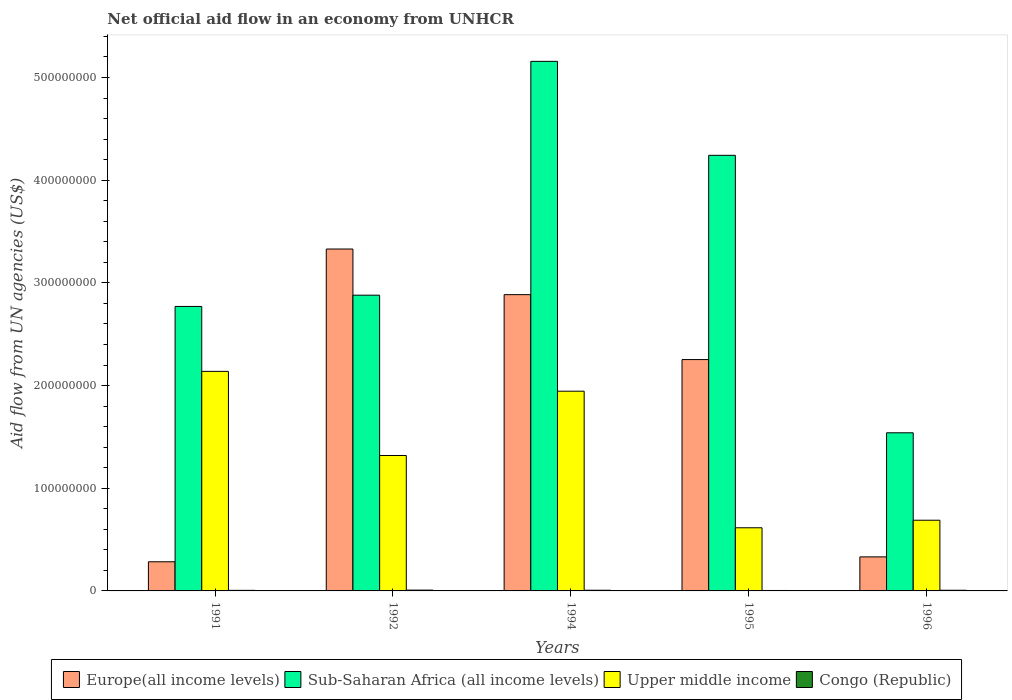Are the number of bars per tick equal to the number of legend labels?
Give a very brief answer. Yes. How many bars are there on the 3rd tick from the right?
Ensure brevity in your answer.  4. In how many cases, is the number of bars for a given year not equal to the number of legend labels?
Make the answer very short. 0. What is the net official aid flow in Upper middle income in 1994?
Provide a succinct answer. 1.94e+08. Across all years, what is the maximum net official aid flow in Europe(all income levels)?
Your response must be concise. 3.33e+08. What is the total net official aid flow in Europe(all income levels) in the graph?
Your response must be concise. 9.08e+08. What is the difference between the net official aid flow in Europe(all income levels) in 1991 and that in 1996?
Your answer should be compact. -4.75e+06. What is the difference between the net official aid flow in Congo (Republic) in 1992 and the net official aid flow in Europe(all income levels) in 1991?
Your answer should be compact. -2.76e+07. What is the average net official aid flow in Upper middle income per year?
Offer a terse response. 1.34e+08. In the year 1991, what is the difference between the net official aid flow in Congo (Republic) and net official aid flow in Upper middle income?
Provide a succinct answer. -2.13e+08. In how many years, is the net official aid flow in Upper middle income greater than 420000000 US$?
Make the answer very short. 0. What is the ratio of the net official aid flow in Upper middle income in 1994 to that in 1996?
Your answer should be compact. 2.83. What is the difference between the highest and the second highest net official aid flow in Sub-Saharan Africa (all income levels)?
Offer a very short reply. 9.15e+07. Is it the case that in every year, the sum of the net official aid flow in Upper middle income and net official aid flow in Sub-Saharan Africa (all income levels) is greater than the sum of net official aid flow in Europe(all income levels) and net official aid flow in Congo (Republic)?
Provide a succinct answer. No. What does the 2nd bar from the left in 1994 represents?
Offer a terse response. Sub-Saharan Africa (all income levels). What does the 4th bar from the right in 1992 represents?
Offer a very short reply. Europe(all income levels). Is it the case that in every year, the sum of the net official aid flow in Europe(all income levels) and net official aid flow in Sub-Saharan Africa (all income levels) is greater than the net official aid flow in Congo (Republic)?
Offer a terse response. Yes. How many years are there in the graph?
Your response must be concise. 5. What is the difference between two consecutive major ticks on the Y-axis?
Your answer should be very brief. 1.00e+08. Are the values on the major ticks of Y-axis written in scientific E-notation?
Ensure brevity in your answer.  No. Does the graph contain grids?
Your answer should be compact. No. Where does the legend appear in the graph?
Make the answer very short. Bottom center. How many legend labels are there?
Provide a short and direct response. 4. What is the title of the graph?
Provide a succinct answer. Net official aid flow in an economy from UNHCR. Does "Papua New Guinea" appear as one of the legend labels in the graph?
Provide a short and direct response. No. What is the label or title of the X-axis?
Give a very brief answer. Years. What is the label or title of the Y-axis?
Your answer should be very brief. Aid flow from UN agencies (US$). What is the Aid flow from UN agencies (US$) of Europe(all income levels) in 1991?
Keep it short and to the point. 2.84e+07. What is the Aid flow from UN agencies (US$) in Sub-Saharan Africa (all income levels) in 1991?
Keep it short and to the point. 2.77e+08. What is the Aid flow from UN agencies (US$) of Upper middle income in 1991?
Offer a very short reply. 2.14e+08. What is the Aid flow from UN agencies (US$) in Congo (Republic) in 1991?
Offer a terse response. 5.50e+05. What is the Aid flow from UN agencies (US$) of Europe(all income levels) in 1992?
Your answer should be compact. 3.33e+08. What is the Aid flow from UN agencies (US$) of Sub-Saharan Africa (all income levels) in 1992?
Ensure brevity in your answer.  2.88e+08. What is the Aid flow from UN agencies (US$) in Upper middle income in 1992?
Keep it short and to the point. 1.32e+08. What is the Aid flow from UN agencies (US$) in Congo (Republic) in 1992?
Your response must be concise. 7.80e+05. What is the Aid flow from UN agencies (US$) in Europe(all income levels) in 1994?
Offer a very short reply. 2.89e+08. What is the Aid flow from UN agencies (US$) of Sub-Saharan Africa (all income levels) in 1994?
Keep it short and to the point. 5.16e+08. What is the Aid flow from UN agencies (US$) of Upper middle income in 1994?
Provide a short and direct response. 1.94e+08. What is the Aid flow from UN agencies (US$) of Congo (Republic) in 1994?
Provide a short and direct response. 6.60e+05. What is the Aid flow from UN agencies (US$) in Europe(all income levels) in 1995?
Make the answer very short. 2.25e+08. What is the Aid flow from UN agencies (US$) in Sub-Saharan Africa (all income levels) in 1995?
Provide a succinct answer. 4.24e+08. What is the Aid flow from UN agencies (US$) in Upper middle income in 1995?
Offer a very short reply. 6.15e+07. What is the Aid flow from UN agencies (US$) of Congo (Republic) in 1995?
Ensure brevity in your answer.  4.30e+05. What is the Aid flow from UN agencies (US$) of Europe(all income levels) in 1996?
Your answer should be very brief. 3.31e+07. What is the Aid flow from UN agencies (US$) of Sub-Saharan Africa (all income levels) in 1996?
Make the answer very short. 1.54e+08. What is the Aid flow from UN agencies (US$) of Upper middle income in 1996?
Your answer should be very brief. 6.88e+07. What is the Aid flow from UN agencies (US$) in Congo (Republic) in 1996?
Provide a short and direct response. 6.50e+05. Across all years, what is the maximum Aid flow from UN agencies (US$) in Europe(all income levels)?
Your answer should be very brief. 3.33e+08. Across all years, what is the maximum Aid flow from UN agencies (US$) of Sub-Saharan Africa (all income levels)?
Offer a very short reply. 5.16e+08. Across all years, what is the maximum Aid flow from UN agencies (US$) of Upper middle income?
Your response must be concise. 2.14e+08. Across all years, what is the maximum Aid flow from UN agencies (US$) of Congo (Republic)?
Your response must be concise. 7.80e+05. Across all years, what is the minimum Aid flow from UN agencies (US$) of Europe(all income levels)?
Your answer should be compact. 2.84e+07. Across all years, what is the minimum Aid flow from UN agencies (US$) in Sub-Saharan Africa (all income levels)?
Provide a short and direct response. 1.54e+08. Across all years, what is the minimum Aid flow from UN agencies (US$) in Upper middle income?
Offer a terse response. 6.15e+07. What is the total Aid flow from UN agencies (US$) of Europe(all income levels) in the graph?
Your answer should be compact. 9.08e+08. What is the total Aid flow from UN agencies (US$) of Sub-Saharan Africa (all income levels) in the graph?
Make the answer very short. 1.66e+09. What is the total Aid flow from UN agencies (US$) of Upper middle income in the graph?
Your response must be concise. 6.71e+08. What is the total Aid flow from UN agencies (US$) of Congo (Republic) in the graph?
Offer a terse response. 3.07e+06. What is the difference between the Aid flow from UN agencies (US$) in Europe(all income levels) in 1991 and that in 1992?
Offer a terse response. -3.05e+08. What is the difference between the Aid flow from UN agencies (US$) of Sub-Saharan Africa (all income levels) in 1991 and that in 1992?
Offer a very short reply. -1.10e+07. What is the difference between the Aid flow from UN agencies (US$) of Upper middle income in 1991 and that in 1992?
Provide a succinct answer. 8.19e+07. What is the difference between the Aid flow from UN agencies (US$) in Europe(all income levels) in 1991 and that in 1994?
Offer a terse response. -2.60e+08. What is the difference between the Aid flow from UN agencies (US$) in Sub-Saharan Africa (all income levels) in 1991 and that in 1994?
Offer a terse response. -2.39e+08. What is the difference between the Aid flow from UN agencies (US$) in Upper middle income in 1991 and that in 1994?
Offer a very short reply. 1.93e+07. What is the difference between the Aid flow from UN agencies (US$) in Europe(all income levels) in 1991 and that in 1995?
Offer a very short reply. -1.97e+08. What is the difference between the Aid flow from UN agencies (US$) in Sub-Saharan Africa (all income levels) in 1991 and that in 1995?
Your response must be concise. -1.47e+08. What is the difference between the Aid flow from UN agencies (US$) of Upper middle income in 1991 and that in 1995?
Keep it short and to the point. 1.52e+08. What is the difference between the Aid flow from UN agencies (US$) in Congo (Republic) in 1991 and that in 1995?
Give a very brief answer. 1.20e+05. What is the difference between the Aid flow from UN agencies (US$) in Europe(all income levels) in 1991 and that in 1996?
Your answer should be compact. -4.75e+06. What is the difference between the Aid flow from UN agencies (US$) in Sub-Saharan Africa (all income levels) in 1991 and that in 1996?
Ensure brevity in your answer.  1.23e+08. What is the difference between the Aid flow from UN agencies (US$) of Upper middle income in 1991 and that in 1996?
Offer a terse response. 1.45e+08. What is the difference between the Aid flow from UN agencies (US$) of Congo (Republic) in 1991 and that in 1996?
Make the answer very short. -1.00e+05. What is the difference between the Aid flow from UN agencies (US$) of Europe(all income levels) in 1992 and that in 1994?
Keep it short and to the point. 4.44e+07. What is the difference between the Aid flow from UN agencies (US$) of Sub-Saharan Africa (all income levels) in 1992 and that in 1994?
Keep it short and to the point. -2.28e+08. What is the difference between the Aid flow from UN agencies (US$) of Upper middle income in 1992 and that in 1994?
Keep it short and to the point. -6.26e+07. What is the difference between the Aid flow from UN agencies (US$) in Europe(all income levels) in 1992 and that in 1995?
Offer a very short reply. 1.08e+08. What is the difference between the Aid flow from UN agencies (US$) of Sub-Saharan Africa (all income levels) in 1992 and that in 1995?
Keep it short and to the point. -1.36e+08. What is the difference between the Aid flow from UN agencies (US$) in Upper middle income in 1992 and that in 1995?
Keep it short and to the point. 7.04e+07. What is the difference between the Aid flow from UN agencies (US$) of Europe(all income levels) in 1992 and that in 1996?
Your response must be concise. 3.00e+08. What is the difference between the Aid flow from UN agencies (US$) of Sub-Saharan Africa (all income levels) in 1992 and that in 1996?
Your answer should be very brief. 1.34e+08. What is the difference between the Aid flow from UN agencies (US$) of Upper middle income in 1992 and that in 1996?
Your answer should be compact. 6.30e+07. What is the difference between the Aid flow from UN agencies (US$) of Congo (Republic) in 1992 and that in 1996?
Your response must be concise. 1.30e+05. What is the difference between the Aid flow from UN agencies (US$) of Europe(all income levels) in 1994 and that in 1995?
Offer a very short reply. 6.32e+07. What is the difference between the Aid flow from UN agencies (US$) in Sub-Saharan Africa (all income levels) in 1994 and that in 1995?
Keep it short and to the point. 9.15e+07. What is the difference between the Aid flow from UN agencies (US$) in Upper middle income in 1994 and that in 1995?
Your response must be concise. 1.33e+08. What is the difference between the Aid flow from UN agencies (US$) in Europe(all income levels) in 1994 and that in 1996?
Offer a terse response. 2.55e+08. What is the difference between the Aid flow from UN agencies (US$) in Sub-Saharan Africa (all income levels) in 1994 and that in 1996?
Provide a succinct answer. 3.62e+08. What is the difference between the Aid flow from UN agencies (US$) in Upper middle income in 1994 and that in 1996?
Give a very brief answer. 1.26e+08. What is the difference between the Aid flow from UN agencies (US$) in Europe(all income levels) in 1995 and that in 1996?
Your response must be concise. 1.92e+08. What is the difference between the Aid flow from UN agencies (US$) of Sub-Saharan Africa (all income levels) in 1995 and that in 1996?
Offer a terse response. 2.70e+08. What is the difference between the Aid flow from UN agencies (US$) in Upper middle income in 1995 and that in 1996?
Your answer should be compact. -7.34e+06. What is the difference between the Aid flow from UN agencies (US$) in Europe(all income levels) in 1991 and the Aid flow from UN agencies (US$) in Sub-Saharan Africa (all income levels) in 1992?
Keep it short and to the point. -2.60e+08. What is the difference between the Aid flow from UN agencies (US$) of Europe(all income levels) in 1991 and the Aid flow from UN agencies (US$) of Upper middle income in 1992?
Your response must be concise. -1.03e+08. What is the difference between the Aid flow from UN agencies (US$) in Europe(all income levels) in 1991 and the Aid flow from UN agencies (US$) in Congo (Republic) in 1992?
Keep it short and to the point. 2.76e+07. What is the difference between the Aid flow from UN agencies (US$) in Sub-Saharan Africa (all income levels) in 1991 and the Aid flow from UN agencies (US$) in Upper middle income in 1992?
Your answer should be compact. 1.45e+08. What is the difference between the Aid flow from UN agencies (US$) in Sub-Saharan Africa (all income levels) in 1991 and the Aid flow from UN agencies (US$) in Congo (Republic) in 1992?
Keep it short and to the point. 2.76e+08. What is the difference between the Aid flow from UN agencies (US$) in Upper middle income in 1991 and the Aid flow from UN agencies (US$) in Congo (Republic) in 1992?
Your answer should be very brief. 2.13e+08. What is the difference between the Aid flow from UN agencies (US$) in Europe(all income levels) in 1991 and the Aid flow from UN agencies (US$) in Sub-Saharan Africa (all income levels) in 1994?
Offer a very short reply. -4.87e+08. What is the difference between the Aid flow from UN agencies (US$) in Europe(all income levels) in 1991 and the Aid flow from UN agencies (US$) in Upper middle income in 1994?
Your answer should be very brief. -1.66e+08. What is the difference between the Aid flow from UN agencies (US$) of Europe(all income levels) in 1991 and the Aid flow from UN agencies (US$) of Congo (Republic) in 1994?
Offer a terse response. 2.77e+07. What is the difference between the Aid flow from UN agencies (US$) of Sub-Saharan Africa (all income levels) in 1991 and the Aid flow from UN agencies (US$) of Upper middle income in 1994?
Give a very brief answer. 8.25e+07. What is the difference between the Aid flow from UN agencies (US$) in Sub-Saharan Africa (all income levels) in 1991 and the Aid flow from UN agencies (US$) in Congo (Republic) in 1994?
Provide a short and direct response. 2.76e+08. What is the difference between the Aid flow from UN agencies (US$) of Upper middle income in 1991 and the Aid flow from UN agencies (US$) of Congo (Republic) in 1994?
Ensure brevity in your answer.  2.13e+08. What is the difference between the Aid flow from UN agencies (US$) of Europe(all income levels) in 1991 and the Aid flow from UN agencies (US$) of Sub-Saharan Africa (all income levels) in 1995?
Your answer should be compact. -3.96e+08. What is the difference between the Aid flow from UN agencies (US$) in Europe(all income levels) in 1991 and the Aid flow from UN agencies (US$) in Upper middle income in 1995?
Keep it short and to the point. -3.31e+07. What is the difference between the Aid flow from UN agencies (US$) in Europe(all income levels) in 1991 and the Aid flow from UN agencies (US$) in Congo (Republic) in 1995?
Your answer should be very brief. 2.80e+07. What is the difference between the Aid flow from UN agencies (US$) of Sub-Saharan Africa (all income levels) in 1991 and the Aid flow from UN agencies (US$) of Upper middle income in 1995?
Your answer should be very brief. 2.16e+08. What is the difference between the Aid flow from UN agencies (US$) in Sub-Saharan Africa (all income levels) in 1991 and the Aid flow from UN agencies (US$) in Congo (Republic) in 1995?
Your response must be concise. 2.77e+08. What is the difference between the Aid flow from UN agencies (US$) in Upper middle income in 1991 and the Aid flow from UN agencies (US$) in Congo (Republic) in 1995?
Keep it short and to the point. 2.13e+08. What is the difference between the Aid flow from UN agencies (US$) in Europe(all income levels) in 1991 and the Aid flow from UN agencies (US$) in Sub-Saharan Africa (all income levels) in 1996?
Offer a very short reply. -1.26e+08. What is the difference between the Aid flow from UN agencies (US$) in Europe(all income levels) in 1991 and the Aid flow from UN agencies (US$) in Upper middle income in 1996?
Your answer should be very brief. -4.04e+07. What is the difference between the Aid flow from UN agencies (US$) in Europe(all income levels) in 1991 and the Aid flow from UN agencies (US$) in Congo (Republic) in 1996?
Your answer should be very brief. 2.77e+07. What is the difference between the Aid flow from UN agencies (US$) in Sub-Saharan Africa (all income levels) in 1991 and the Aid flow from UN agencies (US$) in Upper middle income in 1996?
Provide a succinct answer. 2.08e+08. What is the difference between the Aid flow from UN agencies (US$) in Sub-Saharan Africa (all income levels) in 1991 and the Aid flow from UN agencies (US$) in Congo (Republic) in 1996?
Your answer should be compact. 2.76e+08. What is the difference between the Aid flow from UN agencies (US$) of Upper middle income in 1991 and the Aid flow from UN agencies (US$) of Congo (Republic) in 1996?
Ensure brevity in your answer.  2.13e+08. What is the difference between the Aid flow from UN agencies (US$) in Europe(all income levels) in 1992 and the Aid flow from UN agencies (US$) in Sub-Saharan Africa (all income levels) in 1994?
Make the answer very short. -1.83e+08. What is the difference between the Aid flow from UN agencies (US$) of Europe(all income levels) in 1992 and the Aid flow from UN agencies (US$) of Upper middle income in 1994?
Offer a terse response. 1.38e+08. What is the difference between the Aid flow from UN agencies (US$) in Europe(all income levels) in 1992 and the Aid flow from UN agencies (US$) in Congo (Republic) in 1994?
Make the answer very short. 3.32e+08. What is the difference between the Aid flow from UN agencies (US$) in Sub-Saharan Africa (all income levels) in 1992 and the Aid flow from UN agencies (US$) in Upper middle income in 1994?
Provide a short and direct response. 9.35e+07. What is the difference between the Aid flow from UN agencies (US$) in Sub-Saharan Africa (all income levels) in 1992 and the Aid flow from UN agencies (US$) in Congo (Republic) in 1994?
Your answer should be compact. 2.87e+08. What is the difference between the Aid flow from UN agencies (US$) in Upper middle income in 1992 and the Aid flow from UN agencies (US$) in Congo (Republic) in 1994?
Make the answer very short. 1.31e+08. What is the difference between the Aid flow from UN agencies (US$) in Europe(all income levels) in 1992 and the Aid flow from UN agencies (US$) in Sub-Saharan Africa (all income levels) in 1995?
Offer a very short reply. -9.12e+07. What is the difference between the Aid flow from UN agencies (US$) in Europe(all income levels) in 1992 and the Aid flow from UN agencies (US$) in Upper middle income in 1995?
Give a very brief answer. 2.71e+08. What is the difference between the Aid flow from UN agencies (US$) in Europe(all income levels) in 1992 and the Aid flow from UN agencies (US$) in Congo (Republic) in 1995?
Ensure brevity in your answer.  3.33e+08. What is the difference between the Aid flow from UN agencies (US$) in Sub-Saharan Africa (all income levels) in 1992 and the Aid flow from UN agencies (US$) in Upper middle income in 1995?
Keep it short and to the point. 2.26e+08. What is the difference between the Aid flow from UN agencies (US$) in Sub-Saharan Africa (all income levels) in 1992 and the Aid flow from UN agencies (US$) in Congo (Republic) in 1995?
Offer a very short reply. 2.88e+08. What is the difference between the Aid flow from UN agencies (US$) of Upper middle income in 1992 and the Aid flow from UN agencies (US$) of Congo (Republic) in 1995?
Ensure brevity in your answer.  1.31e+08. What is the difference between the Aid flow from UN agencies (US$) of Europe(all income levels) in 1992 and the Aid flow from UN agencies (US$) of Sub-Saharan Africa (all income levels) in 1996?
Provide a short and direct response. 1.79e+08. What is the difference between the Aid flow from UN agencies (US$) in Europe(all income levels) in 1992 and the Aid flow from UN agencies (US$) in Upper middle income in 1996?
Provide a succinct answer. 2.64e+08. What is the difference between the Aid flow from UN agencies (US$) of Europe(all income levels) in 1992 and the Aid flow from UN agencies (US$) of Congo (Republic) in 1996?
Ensure brevity in your answer.  3.32e+08. What is the difference between the Aid flow from UN agencies (US$) in Sub-Saharan Africa (all income levels) in 1992 and the Aid flow from UN agencies (US$) in Upper middle income in 1996?
Ensure brevity in your answer.  2.19e+08. What is the difference between the Aid flow from UN agencies (US$) in Sub-Saharan Africa (all income levels) in 1992 and the Aid flow from UN agencies (US$) in Congo (Republic) in 1996?
Your answer should be compact. 2.87e+08. What is the difference between the Aid flow from UN agencies (US$) of Upper middle income in 1992 and the Aid flow from UN agencies (US$) of Congo (Republic) in 1996?
Give a very brief answer. 1.31e+08. What is the difference between the Aid flow from UN agencies (US$) of Europe(all income levels) in 1994 and the Aid flow from UN agencies (US$) of Sub-Saharan Africa (all income levels) in 1995?
Make the answer very short. -1.36e+08. What is the difference between the Aid flow from UN agencies (US$) in Europe(all income levels) in 1994 and the Aid flow from UN agencies (US$) in Upper middle income in 1995?
Make the answer very short. 2.27e+08. What is the difference between the Aid flow from UN agencies (US$) of Europe(all income levels) in 1994 and the Aid flow from UN agencies (US$) of Congo (Republic) in 1995?
Keep it short and to the point. 2.88e+08. What is the difference between the Aid flow from UN agencies (US$) in Sub-Saharan Africa (all income levels) in 1994 and the Aid flow from UN agencies (US$) in Upper middle income in 1995?
Give a very brief answer. 4.54e+08. What is the difference between the Aid flow from UN agencies (US$) of Sub-Saharan Africa (all income levels) in 1994 and the Aid flow from UN agencies (US$) of Congo (Republic) in 1995?
Your answer should be compact. 5.15e+08. What is the difference between the Aid flow from UN agencies (US$) in Upper middle income in 1994 and the Aid flow from UN agencies (US$) in Congo (Republic) in 1995?
Your answer should be compact. 1.94e+08. What is the difference between the Aid flow from UN agencies (US$) in Europe(all income levels) in 1994 and the Aid flow from UN agencies (US$) in Sub-Saharan Africa (all income levels) in 1996?
Make the answer very short. 1.35e+08. What is the difference between the Aid flow from UN agencies (US$) in Europe(all income levels) in 1994 and the Aid flow from UN agencies (US$) in Upper middle income in 1996?
Offer a very short reply. 2.20e+08. What is the difference between the Aid flow from UN agencies (US$) in Europe(all income levels) in 1994 and the Aid flow from UN agencies (US$) in Congo (Republic) in 1996?
Offer a terse response. 2.88e+08. What is the difference between the Aid flow from UN agencies (US$) in Sub-Saharan Africa (all income levels) in 1994 and the Aid flow from UN agencies (US$) in Upper middle income in 1996?
Give a very brief answer. 4.47e+08. What is the difference between the Aid flow from UN agencies (US$) in Sub-Saharan Africa (all income levels) in 1994 and the Aid flow from UN agencies (US$) in Congo (Republic) in 1996?
Make the answer very short. 5.15e+08. What is the difference between the Aid flow from UN agencies (US$) in Upper middle income in 1994 and the Aid flow from UN agencies (US$) in Congo (Republic) in 1996?
Your answer should be very brief. 1.94e+08. What is the difference between the Aid flow from UN agencies (US$) in Europe(all income levels) in 1995 and the Aid flow from UN agencies (US$) in Sub-Saharan Africa (all income levels) in 1996?
Offer a terse response. 7.13e+07. What is the difference between the Aid flow from UN agencies (US$) of Europe(all income levels) in 1995 and the Aid flow from UN agencies (US$) of Upper middle income in 1996?
Ensure brevity in your answer.  1.56e+08. What is the difference between the Aid flow from UN agencies (US$) in Europe(all income levels) in 1995 and the Aid flow from UN agencies (US$) in Congo (Republic) in 1996?
Ensure brevity in your answer.  2.25e+08. What is the difference between the Aid flow from UN agencies (US$) in Sub-Saharan Africa (all income levels) in 1995 and the Aid flow from UN agencies (US$) in Upper middle income in 1996?
Offer a terse response. 3.55e+08. What is the difference between the Aid flow from UN agencies (US$) in Sub-Saharan Africa (all income levels) in 1995 and the Aid flow from UN agencies (US$) in Congo (Republic) in 1996?
Your answer should be compact. 4.24e+08. What is the difference between the Aid flow from UN agencies (US$) of Upper middle income in 1995 and the Aid flow from UN agencies (US$) of Congo (Republic) in 1996?
Offer a very short reply. 6.08e+07. What is the average Aid flow from UN agencies (US$) of Europe(all income levels) per year?
Provide a succinct answer. 1.82e+08. What is the average Aid flow from UN agencies (US$) of Sub-Saharan Africa (all income levels) per year?
Offer a terse response. 3.32e+08. What is the average Aid flow from UN agencies (US$) in Upper middle income per year?
Ensure brevity in your answer.  1.34e+08. What is the average Aid flow from UN agencies (US$) in Congo (Republic) per year?
Offer a very short reply. 6.14e+05. In the year 1991, what is the difference between the Aid flow from UN agencies (US$) of Europe(all income levels) and Aid flow from UN agencies (US$) of Sub-Saharan Africa (all income levels)?
Give a very brief answer. -2.49e+08. In the year 1991, what is the difference between the Aid flow from UN agencies (US$) of Europe(all income levels) and Aid flow from UN agencies (US$) of Upper middle income?
Provide a short and direct response. -1.85e+08. In the year 1991, what is the difference between the Aid flow from UN agencies (US$) of Europe(all income levels) and Aid flow from UN agencies (US$) of Congo (Republic)?
Make the answer very short. 2.78e+07. In the year 1991, what is the difference between the Aid flow from UN agencies (US$) in Sub-Saharan Africa (all income levels) and Aid flow from UN agencies (US$) in Upper middle income?
Offer a terse response. 6.32e+07. In the year 1991, what is the difference between the Aid flow from UN agencies (US$) of Sub-Saharan Africa (all income levels) and Aid flow from UN agencies (US$) of Congo (Republic)?
Your response must be concise. 2.76e+08. In the year 1991, what is the difference between the Aid flow from UN agencies (US$) of Upper middle income and Aid flow from UN agencies (US$) of Congo (Republic)?
Your response must be concise. 2.13e+08. In the year 1992, what is the difference between the Aid flow from UN agencies (US$) of Europe(all income levels) and Aid flow from UN agencies (US$) of Sub-Saharan Africa (all income levels)?
Provide a short and direct response. 4.50e+07. In the year 1992, what is the difference between the Aid flow from UN agencies (US$) of Europe(all income levels) and Aid flow from UN agencies (US$) of Upper middle income?
Your answer should be very brief. 2.01e+08. In the year 1992, what is the difference between the Aid flow from UN agencies (US$) in Europe(all income levels) and Aid flow from UN agencies (US$) in Congo (Republic)?
Ensure brevity in your answer.  3.32e+08. In the year 1992, what is the difference between the Aid flow from UN agencies (US$) of Sub-Saharan Africa (all income levels) and Aid flow from UN agencies (US$) of Upper middle income?
Make the answer very short. 1.56e+08. In the year 1992, what is the difference between the Aid flow from UN agencies (US$) of Sub-Saharan Africa (all income levels) and Aid flow from UN agencies (US$) of Congo (Republic)?
Your answer should be very brief. 2.87e+08. In the year 1992, what is the difference between the Aid flow from UN agencies (US$) of Upper middle income and Aid flow from UN agencies (US$) of Congo (Republic)?
Offer a terse response. 1.31e+08. In the year 1994, what is the difference between the Aid flow from UN agencies (US$) of Europe(all income levels) and Aid flow from UN agencies (US$) of Sub-Saharan Africa (all income levels)?
Your answer should be very brief. -2.27e+08. In the year 1994, what is the difference between the Aid flow from UN agencies (US$) in Europe(all income levels) and Aid flow from UN agencies (US$) in Upper middle income?
Make the answer very short. 9.40e+07. In the year 1994, what is the difference between the Aid flow from UN agencies (US$) in Europe(all income levels) and Aid flow from UN agencies (US$) in Congo (Republic)?
Your answer should be very brief. 2.88e+08. In the year 1994, what is the difference between the Aid flow from UN agencies (US$) in Sub-Saharan Africa (all income levels) and Aid flow from UN agencies (US$) in Upper middle income?
Offer a very short reply. 3.21e+08. In the year 1994, what is the difference between the Aid flow from UN agencies (US$) in Sub-Saharan Africa (all income levels) and Aid flow from UN agencies (US$) in Congo (Republic)?
Provide a short and direct response. 5.15e+08. In the year 1994, what is the difference between the Aid flow from UN agencies (US$) of Upper middle income and Aid flow from UN agencies (US$) of Congo (Republic)?
Ensure brevity in your answer.  1.94e+08. In the year 1995, what is the difference between the Aid flow from UN agencies (US$) in Europe(all income levels) and Aid flow from UN agencies (US$) in Sub-Saharan Africa (all income levels)?
Your answer should be compact. -1.99e+08. In the year 1995, what is the difference between the Aid flow from UN agencies (US$) in Europe(all income levels) and Aid flow from UN agencies (US$) in Upper middle income?
Offer a terse response. 1.64e+08. In the year 1995, what is the difference between the Aid flow from UN agencies (US$) in Europe(all income levels) and Aid flow from UN agencies (US$) in Congo (Republic)?
Make the answer very short. 2.25e+08. In the year 1995, what is the difference between the Aid flow from UN agencies (US$) in Sub-Saharan Africa (all income levels) and Aid flow from UN agencies (US$) in Upper middle income?
Provide a succinct answer. 3.63e+08. In the year 1995, what is the difference between the Aid flow from UN agencies (US$) of Sub-Saharan Africa (all income levels) and Aid flow from UN agencies (US$) of Congo (Republic)?
Keep it short and to the point. 4.24e+08. In the year 1995, what is the difference between the Aid flow from UN agencies (US$) of Upper middle income and Aid flow from UN agencies (US$) of Congo (Republic)?
Offer a very short reply. 6.11e+07. In the year 1996, what is the difference between the Aid flow from UN agencies (US$) of Europe(all income levels) and Aid flow from UN agencies (US$) of Sub-Saharan Africa (all income levels)?
Provide a succinct answer. -1.21e+08. In the year 1996, what is the difference between the Aid flow from UN agencies (US$) of Europe(all income levels) and Aid flow from UN agencies (US$) of Upper middle income?
Offer a terse response. -3.57e+07. In the year 1996, what is the difference between the Aid flow from UN agencies (US$) in Europe(all income levels) and Aid flow from UN agencies (US$) in Congo (Republic)?
Ensure brevity in your answer.  3.25e+07. In the year 1996, what is the difference between the Aid flow from UN agencies (US$) in Sub-Saharan Africa (all income levels) and Aid flow from UN agencies (US$) in Upper middle income?
Offer a terse response. 8.52e+07. In the year 1996, what is the difference between the Aid flow from UN agencies (US$) in Sub-Saharan Africa (all income levels) and Aid flow from UN agencies (US$) in Congo (Republic)?
Offer a very short reply. 1.53e+08. In the year 1996, what is the difference between the Aid flow from UN agencies (US$) of Upper middle income and Aid flow from UN agencies (US$) of Congo (Republic)?
Keep it short and to the point. 6.82e+07. What is the ratio of the Aid flow from UN agencies (US$) of Europe(all income levels) in 1991 to that in 1992?
Your response must be concise. 0.09. What is the ratio of the Aid flow from UN agencies (US$) in Sub-Saharan Africa (all income levels) in 1991 to that in 1992?
Your response must be concise. 0.96. What is the ratio of the Aid flow from UN agencies (US$) in Upper middle income in 1991 to that in 1992?
Your answer should be very brief. 1.62. What is the ratio of the Aid flow from UN agencies (US$) of Congo (Republic) in 1991 to that in 1992?
Provide a short and direct response. 0.71. What is the ratio of the Aid flow from UN agencies (US$) of Europe(all income levels) in 1991 to that in 1994?
Offer a terse response. 0.1. What is the ratio of the Aid flow from UN agencies (US$) of Sub-Saharan Africa (all income levels) in 1991 to that in 1994?
Offer a terse response. 0.54. What is the ratio of the Aid flow from UN agencies (US$) of Upper middle income in 1991 to that in 1994?
Keep it short and to the point. 1.1. What is the ratio of the Aid flow from UN agencies (US$) of Europe(all income levels) in 1991 to that in 1995?
Provide a short and direct response. 0.13. What is the ratio of the Aid flow from UN agencies (US$) of Sub-Saharan Africa (all income levels) in 1991 to that in 1995?
Keep it short and to the point. 0.65. What is the ratio of the Aid flow from UN agencies (US$) in Upper middle income in 1991 to that in 1995?
Your answer should be very brief. 3.48. What is the ratio of the Aid flow from UN agencies (US$) of Congo (Republic) in 1991 to that in 1995?
Your answer should be compact. 1.28. What is the ratio of the Aid flow from UN agencies (US$) of Europe(all income levels) in 1991 to that in 1996?
Offer a very short reply. 0.86. What is the ratio of the Aid flow from UN agencies (US$) in Sub-Saharan Africa (all income levels) in 1991 to that in 1996?
Keep it short and to the point. 1.8. What is the ratio of the Aid flow from UN agencies (US$) of Upper middle income in 1991 to that in 1996?
Ensure brevity in your answer.  3.11. What is the ratio of the Aid flow from UN agencies (US$) of Congo (Republic) in 1991 to that in 1996?
Provide a succinct answer. 0.85. What is the ratio of the Aid flow from UN agencies (US$) of Europe(all income levels) in 1992 to that in 1994?
Your answer should be very brief. 1.15. What is the ratio of the Aid flow from UN agencies (US$) of Sub-Saharan Africa (all income levels) in 1992 to that in 1994?
Offer a very short reply. 0.56. What is the ratio of the Aid flow from UN agencies (US$) in Upper middle income in 1992 to that in 1994?
Offer a very short reply. 0.68. What is the ratio of the Aid flow from UN agencies (US$) of Congo (Republic) in 1992 to that in 1994?
Provide a succinct answer. 1.18. What is the ratio of the Aid flow from UN agencies (US$) in Europe(all income levels) in 1992 to that in 1995?
Make the answer very short. 1.48. What is the ratio of the Aid flow from UN agencies (US$) of Sub-Saharan Africa (all income levels) in 1992 to that in 1995?
Make the answer very short. 0.68. What is the ratio of the Aid flow from UN agencies (US$) in Upper middle income in 1992 to that in 1995?
Your response must be concise. 2.14. What is the ratio of the Aid flow from UN agencies (US$) in Congo (Republic) in 1992 to that in 1995?
Your answer should be compact. 1.81. What is the ratio of the Aid flow from UN agencies (US$) of Europe(all income levels) in 1992 to that in 1996?
Offer a very short reply. 10.05. What is the ratio of the Aid flow from UN agencies (US$) in Sub-Saharan Africa (all income levels) in 1992 to that in 1996?
Offer a very short reply. 1.87. What is the ratio of the Aid flow from UN agencies (US$) in Upper middle income in 1992 to that in 1996?
Ensure brevity in your answer.  1.92. What is the ratio of the Aid flow from UN agencies (US$) in Europe(all income levels) in 1994 to that in 1995?
Provide a succinct answer. 1.28. What is the ratio of the Aid flow from UN agencies (US$) in Sub-Saharan Africa (all income levels) in 1994 to that in 1995?
Your answer should be compact. 1.22. What is the ratio of the Aid flow from UN agencies (US$) in Upper middle income in 1994 to that in 1995?
Ensure brevity in your answer.  3.16. What is the ratio of the Aid flow from UN agencies (US$) in Congo (Republic) in 1994 to that in 1995?
Provide a short and direct response. 1.53. What is the ratio of the Aid flow from UN agencies (US$) of Europe(all income levels) in 1994 to that in 1996?
Ensure brevity in your answer.  8.71. What is the ratio of the Aid flow from UN agencies (US$) of Sub-Saharan Africa (all income levels) in 1994 to that in 1996?
Make the answer very short. 3.35. What is the ratio of the Aid flow from UN agencies (US$) of Upper middle income in 1994 to that in 1996?
Give a very brief answer. 2.83. What is the ratio of the Aid flow from UN agencies (US$) of Congo (Republic) in 1994 to that in 1996?
Offer a terse response. 1.02. What is the ratio of the Aid flow from UN agencies (US$) of Europe(all income levels) in 1995 to that in 1996?
Offer a very short reply. 6.8. What is the ratio of the Aid flow from UN agencies (US$) in Sub-Saharan Africa (all income levels) in 1995 to that in 1996?
Your answer should be very brief. 2.75. What is the ratio of the Aid flow from UN agencies (US$) of Upper middle income in 1995 to that in 1996?
Provide a short and direct response. 0.89. What is the ratio of the Aid flow from UN agencies (US$) of Congo (Republic) in 1995 to that in 1996?
Ensure brevity in your answer.  0.66. What is the difference between the highest and the second highest Aid flow from UN agencies (US$) of Europe(all income levels)?
Provide a short and direct response. 4.44e+07. What is the difference between the highest and the second highest Aid flow from UN agencies (US$) in Sub-Saharan Africa (all income levels)?
Make the answer very short. 9.15e+07. What is the difference between the highest and the second highest Aid flow from UN agencies (US$) in Upper middle income?
Offer a very short reply. 1.93e+07. What is the difference between the highest and the lowest Aid flow from UN agencies (US$) of Europe(all income levels)?
Ensure brevity in your answer.  3.05e+08. What is the difference between the highest and the lowest Aid flow from UN agencies (US$) in Sub-Saharan Africa (all income levels)?
Offer a terse response. 3.62e+08. What is the difference between the highest and the lowest Aid flow from UN agencies (US$) in Upper middle income?
Your answer should be compact. 1.52e+08. What is the difference between the highest and the lowest Aid flow from UN agencies (US$) of Congo (Republic)?
Ensure brevity in your answer.  3.50e+05. 